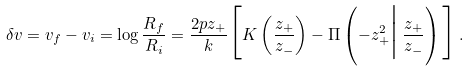Convert formula to latex. <formula><loc_0><loc_0><loc_500><loc_500>\delta v = v _ { f } - v _ { i } = \log \frac { R _ { f } } { R _ { i } } = \frac { 2 p z _ { + } } { k } \Big [ K \left ( \frac { z _ { + } } { z _ { - } } \right ) - \Pi \left ( - z _ { + } ^ { 2 } \Big | \, \frac { z _ { + } } { z _ { - } } \right ) \Big ] \, .</formula> 